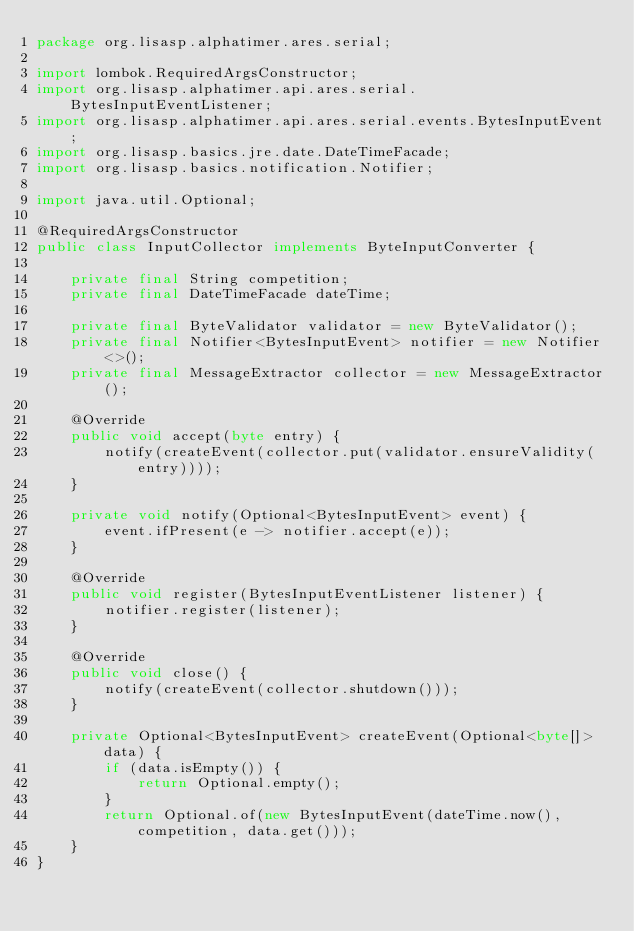<code> <loc_0><loc_0><loc_500><loc_500><_Java_>package org.lisasp.alphatimer.ares.serial;

import lombok.RequiredArgsConstructor;
import org.lisasp.alphatimer.api.ares.serial.BytesInputEventListener;
import org.lisasp.alphatimer.api.ares.serial.events.BytesInputEvent;
import org.lisasp.basics.jre.date.DateTimeFacade;
import org.lisasp.basics.notification.Notifier;

import java.util.Optional;

@RequiredArgsConstructor
public class InputCollector implements ByteInputConverter {

    private final String competition;
    private final DateTimeFacade dateTime;

    private final ByteValidator validator = new ByteValidator();
    private final Notifier<BytesInputEvent> notifier = new Notifier<>();
    private final MessageExtractor collector = new MessageExtractor();

    @Override
    public void accept(byte entry) {
        notify(createEvent(collector.put(validator.ensureValidity(entry))));
    }

    private void notify(Optional<BytesInputEvent> event) {
        event.ifPresent(e -> notifier.accept(e));
    }

    @Override
    public void register(BytesInputEventListener listener) {
        notifier.register(listener);
    }

    @Override
    public void close() {
        notify(createEvent(collector.shutdown()));
    }

    private Optional<BytesInputEvent> createEvent(Optional<byte[]> data) {
        if (data.isEmpty()) {
            return Optional.empty();
        }
        return Optional.of(new BytesInputEvent(dateTime.now(), competition, data.get()));
    }
}
</code> 